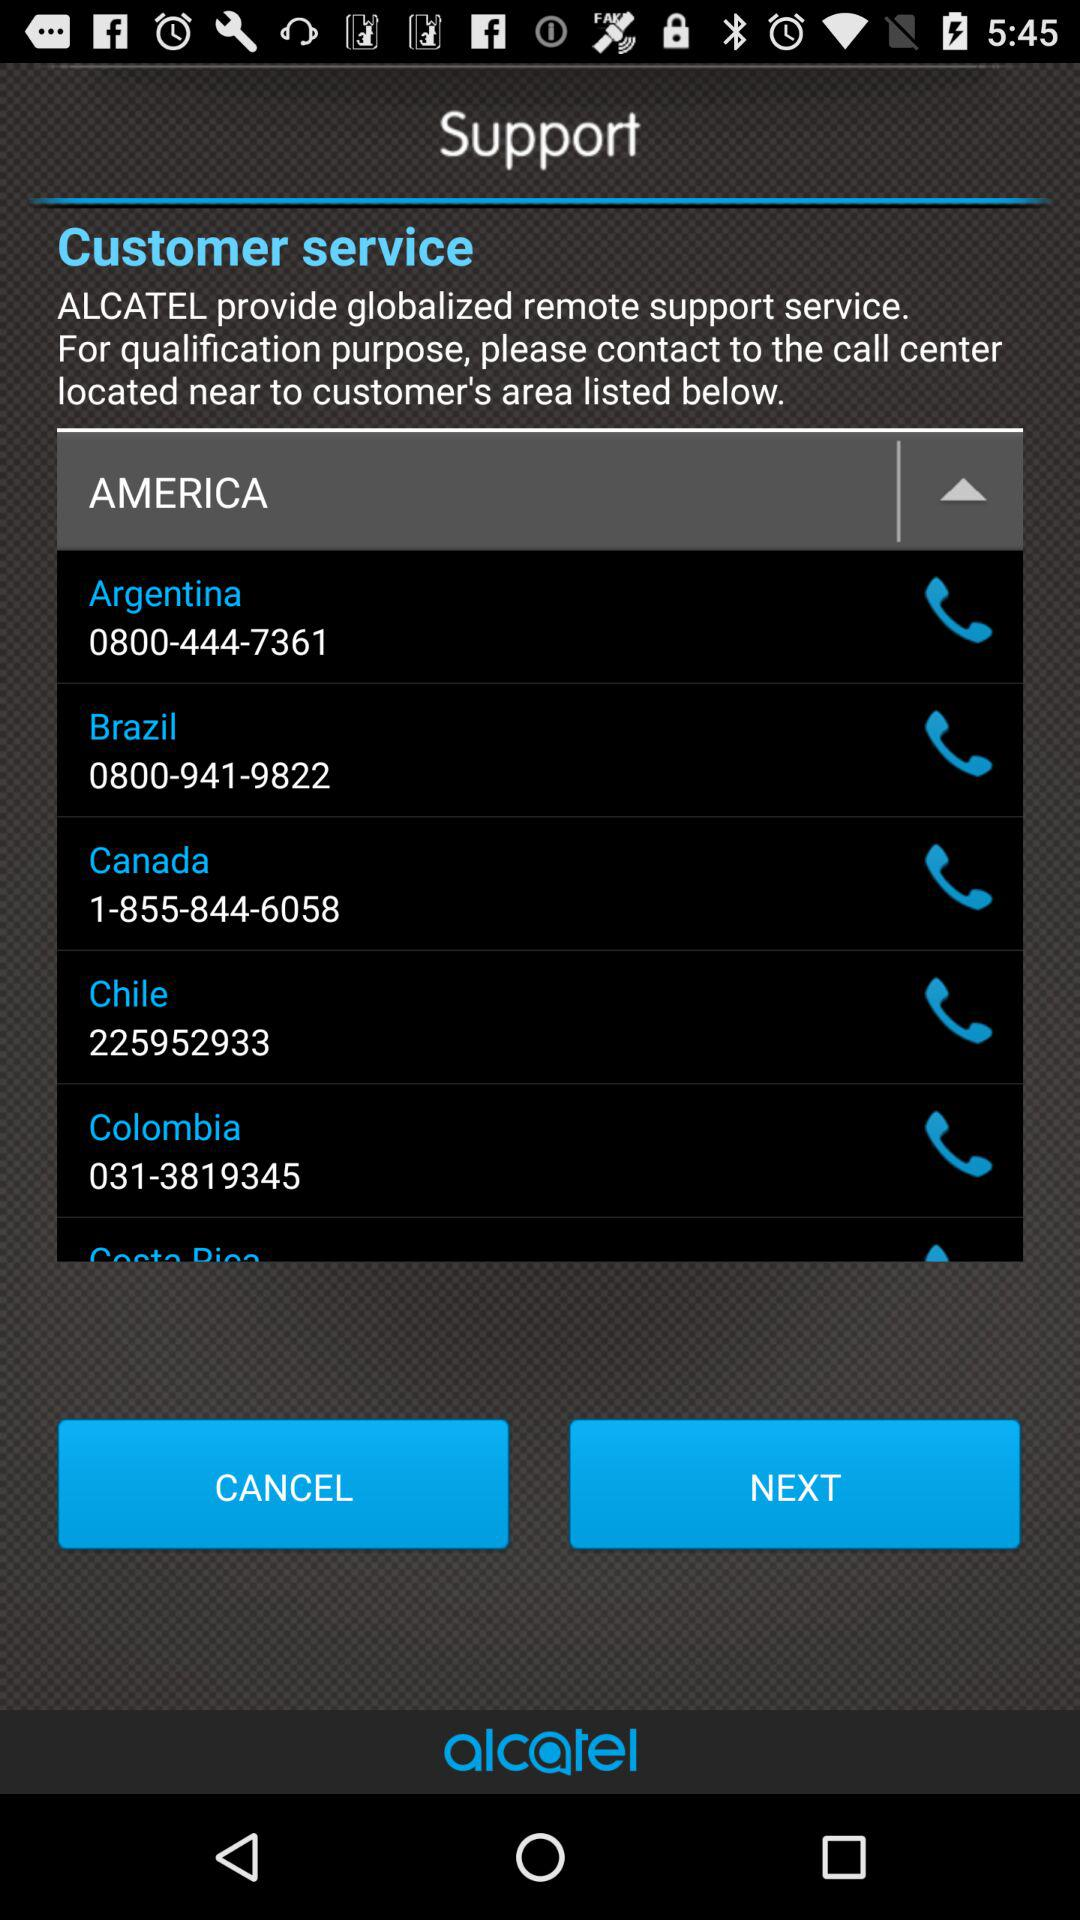What is the number for Argentina? The number for Argentina is 0800-444-7361. 